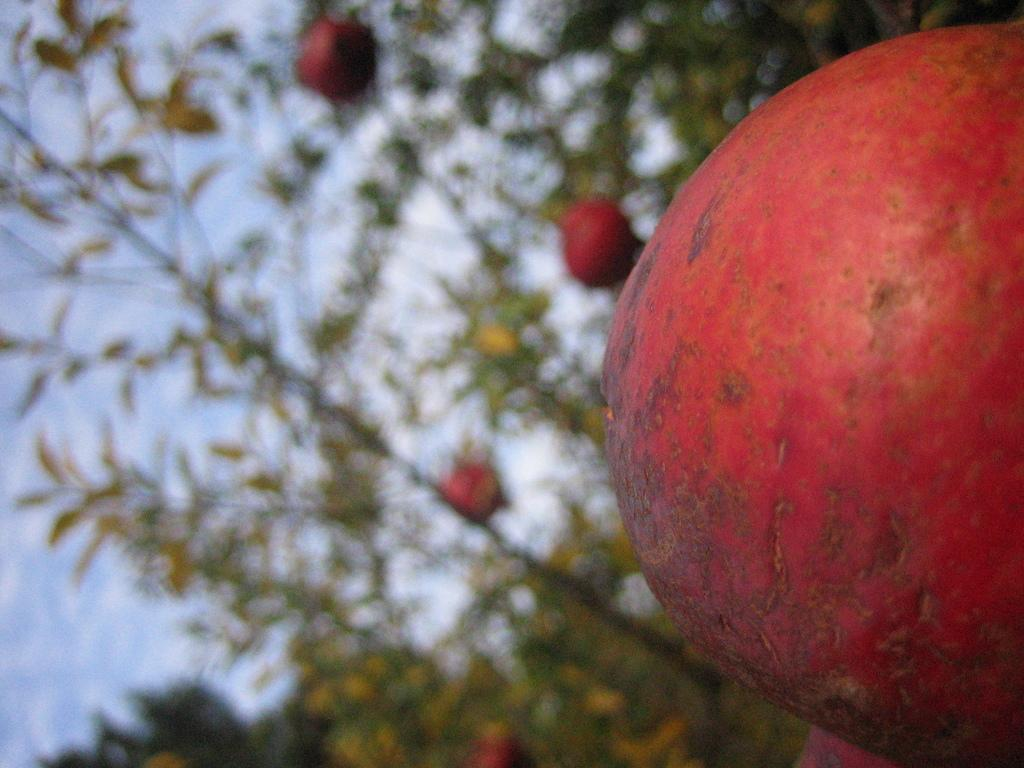What type of food can be seen in the image? There are fruits in the image. Can you describe the background of the image? The background of the image is blurry. What part of the natural environment is visible in the image? The sky is visible in the background of the image. How many flowers are present in the image? There are no flowers present in the image; it features fruits and a blurry background with the sky visible. What type of attention are the snails giving to the fruits in the image? There are no snails present in the image, so it is not possible to determine what type of attention they might be giving to the fruits. 